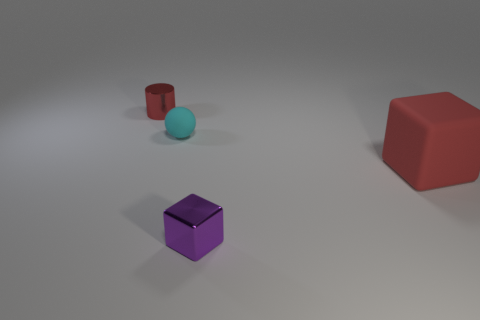What number of other objects are there of the same size as the rubber cube?
Your answer should be very brief. 0. Are the thing that is in front of the large red block and the tiny cylinder made of the same material?
Offer a terse response. Yes. How many other objects are there of the same color as the metal cylinder?
Provide a succinct answer. 1. What number of other objects are there of the same shape as the small cyan thing?
Keep it short and to the point. 0. There is a metallic object that is on the right side of the red cylinder; is its shape the same as the red object that is in front of the small red thing?
Offer a terse response. Yes. Is the number of small cylinders to the left of the shiny block the same as the number of red matte things that are to the left of the tiny cylinder?
Your answer should be very brief. No. There is a red metal object to the left of the small shiny object that is in front of the red thing on the right side of the tiny red metal cylinder; what shape is it?
Provide a succinct answer. Cylinder. Do the object that is in front of the red cube and the cube behind the shiny block have the same material?
Give a very brief answer. No. There is a small metal thing that is right of the tiny red object; what shape is it?
Keep it short and to the point. Cube. Is the number of big blue metal cylinders less than the number of large red rubber things?
Provide a short and direct response. Yes. 